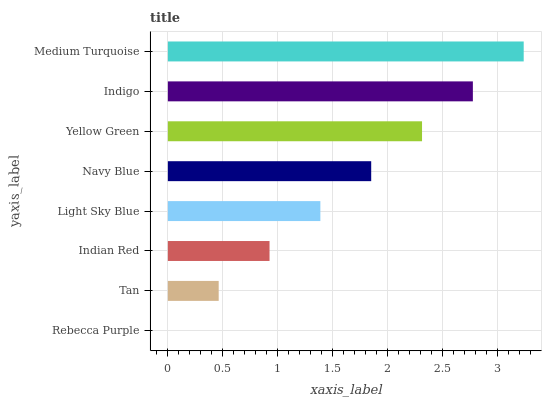Is Rebecca Purple the minimum?
Answer yes or no. Yes. Is Medium Turquoise the maximum?
Answer yes or no. Yes. Is Tan the minimum?
Answer yes or no. No. Is Tan the maximum?
Answer yes or no. No. Is Tan greater than Rebecca Purple?
Answer yes or no. Yes. Is Rebecca Purple less than Tan?
Answer yes or no. Yes. Is Rebecca Purple greater than Tan?
Answer yes or no. No. Is Tan less than Rebecca Purple?
Answer yes or no. No. Is Navy Blue the high median?
Answer yes or no. Yes. Is Light Sky Blue the low median?
Answer yes or no. Yes. Is Yellow Green the high median?
Answer yes or no. No. Is Medium Turquoise the low median?
Answer yes or no. No. 